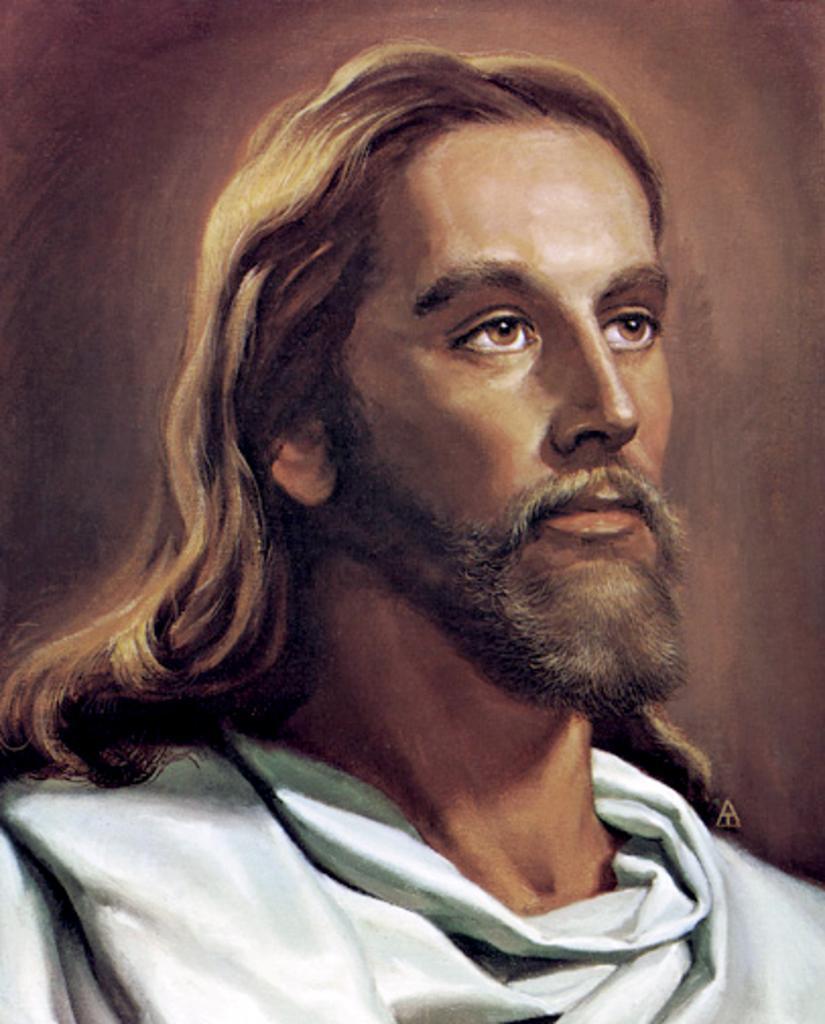Can you describe this image briefly? In this image there is a painting of a person. 